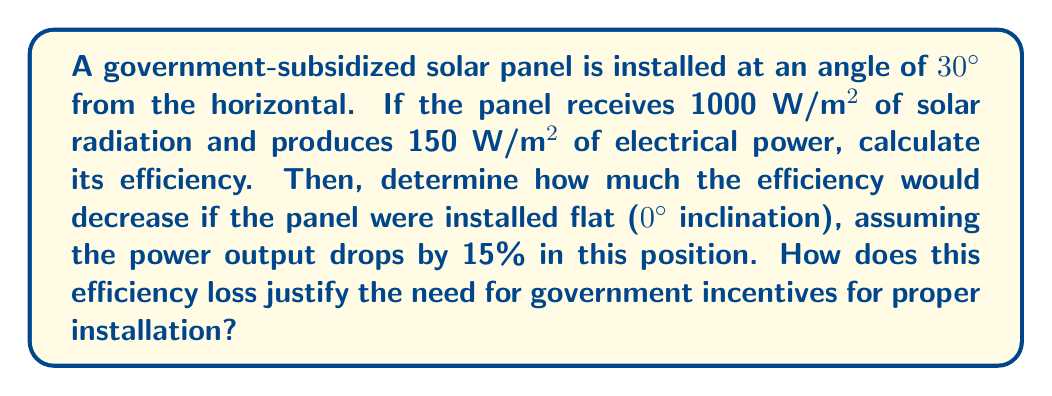Could you help me with this problem? 1) First, calculate the efficiency of the panel at 30° inclination:

   Efficiency = $\frac{\text{Output Power}}{\text{Input Power}} \times 100\%$

   $$ \text{Efficiency} = \frac{150 \text{ W/m²}}{1000 \text{ W/m²}} \times 100\% = 15\% $$

2) For the flat position (0° inclination), the power output drops by 15%:

   New output power = $150 \text{ W/m²} \times (1 - 0.15) = 127.5 \text{ W/m²}$

3) Calculate the new efficiency:

   $$ \text{New Efficiency} = \frac{127.5 \text{ W/m²}}{1000 \text{ W/m²}} \times 100\% = 12.75\% $$

4) Calculate the efficiency decrease:

   $$ \text{Efficiency Decrease} = 15\% - 12.75\% = 2.25\% $$

This significant drop in efficiency (15% relative decrease) due to improper installation angle demonstrates why government incentives might be necessary to ensure optimal positioning and maximum energy production from solar panels.
Answer: 15% efficiency at 30°; 12.75% at 0°; 2.25% efficiency loss 